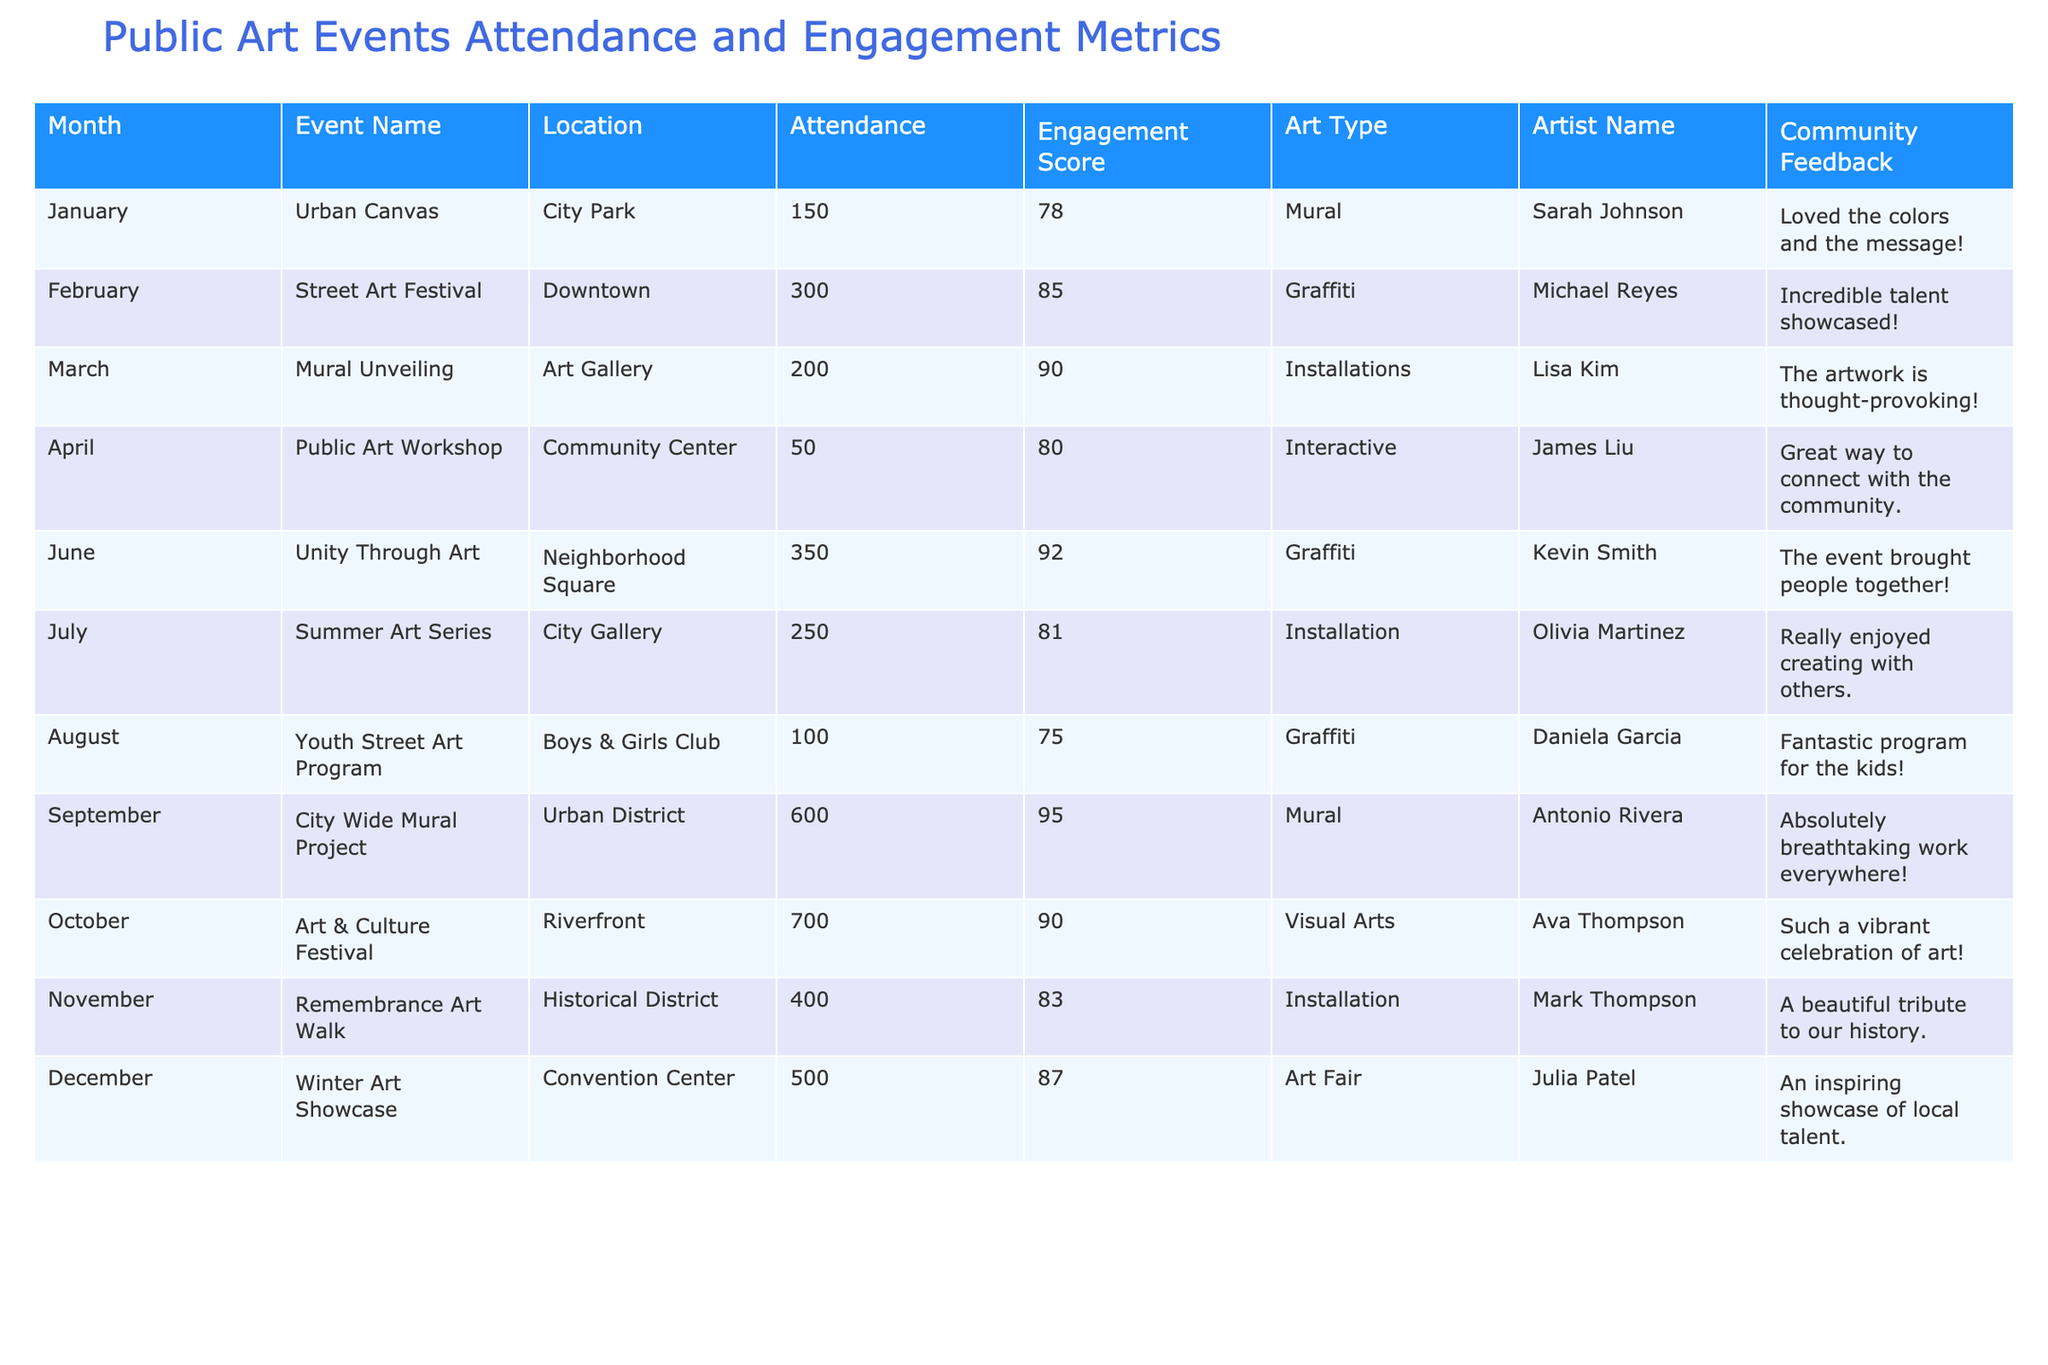What is the attendance at the Street Art Festival in February? The table shows an entry for the Street Art Festival in February, with an attendance of 300 people listed under the Attendance column.
Answer: 300 Which event had the highest engagement score? By examining the Engagement Score column, the City Wide Mural Project has the highest score of 95 compared to other events.
Answer: City Wide Mural Project What is the average attendance for all events listed? The attendance figures are: 150, 300, 200, 50, 350, 250, 100, 600, 700, 400, and 500. The total attendance is 2900, and with 11 events, the average is 2900/11 ≈ 263.64.
Answer: Approximately 264 Was there any event that received community feedback specifically mentioning enjoyment for children? In the Youth Street Art Program entry, the feedback states it was a "Fantastic program for the kids!" This indicates it was appreciated by children.
Answer: Yes Which artist had the highest attendance for their event? The City Wide Mural Project, featuring artist Antonio Rivera, attracted the highest attendance of 600 people.
Answer: Antonio Rivera How much higher is the engagement score of the Unity Through Art event compared to the Public Art Workshop? The Unity Through Art event has an engagement score of 92, while the Public Art Workshop has an engagement score of 80. The difference is 92 - 80 = 12.
Answer: 12 What percentage of the total attendance was attributed to the Art & Culture Festival? The Art & Culture Festival had an attendance of 700. The total attendance across all events is 2900. The percentage is (700/2900) * 100 ≈ 24.14%.
Answer: Approximately 24.14% Which month had the lowest attendance, and what was the attendance figure? The Public Art Workshop in April had the lowest attendance with only 50 people attending.
Answer: April, 50 How would you describe the trend of attendance from January to October based on the data? By reviewing the figures, attendance generally increased from January (150) to October (700), peaking significantly in September and October.
Answer: Increasing trend Is there a month where more than 500 attendees participated in public art events? Yes, the months of September (600) and October (700) recorded more than 500 attendees.
Answer: Yes 